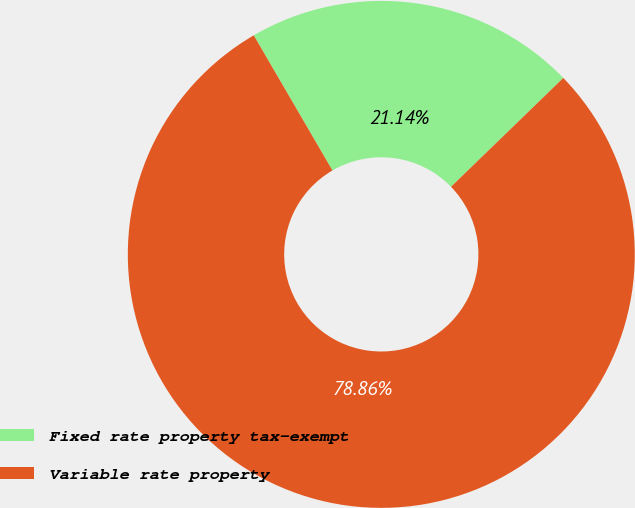Convert chart. <chart><loc_0><loc_0><loc_500><loc_500><pie_chart><fcel>Fixed rate property tax-exempt<fcel>Variable rate property<nl><fcel>21.14%<fcel>78.86%<nl></chart> 